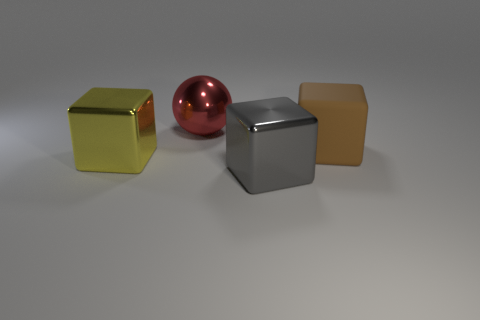Add 3 brown blocks. How many objects exist? 7 Subtract all big shiny cubes. How many cubes are left? 1 Subtract 3 blocks. How many blocks are left? 0 Subtract all spheres. How many objects are left? 3 Subtract 0 brown cylinders. How many objects are left? 4 Subtract all blue blocks. Subtract all yellow spheres. How many blocks are left? 3 Subtract all red metal things. Subtract all big red shiny things. How many objects are left? 2 Add 3 red objects. How many red objects are left? 4 Add 3 gray balls. How many gray balls exist? 3 Subtract all gray cubes. How many cubes are left? 2 